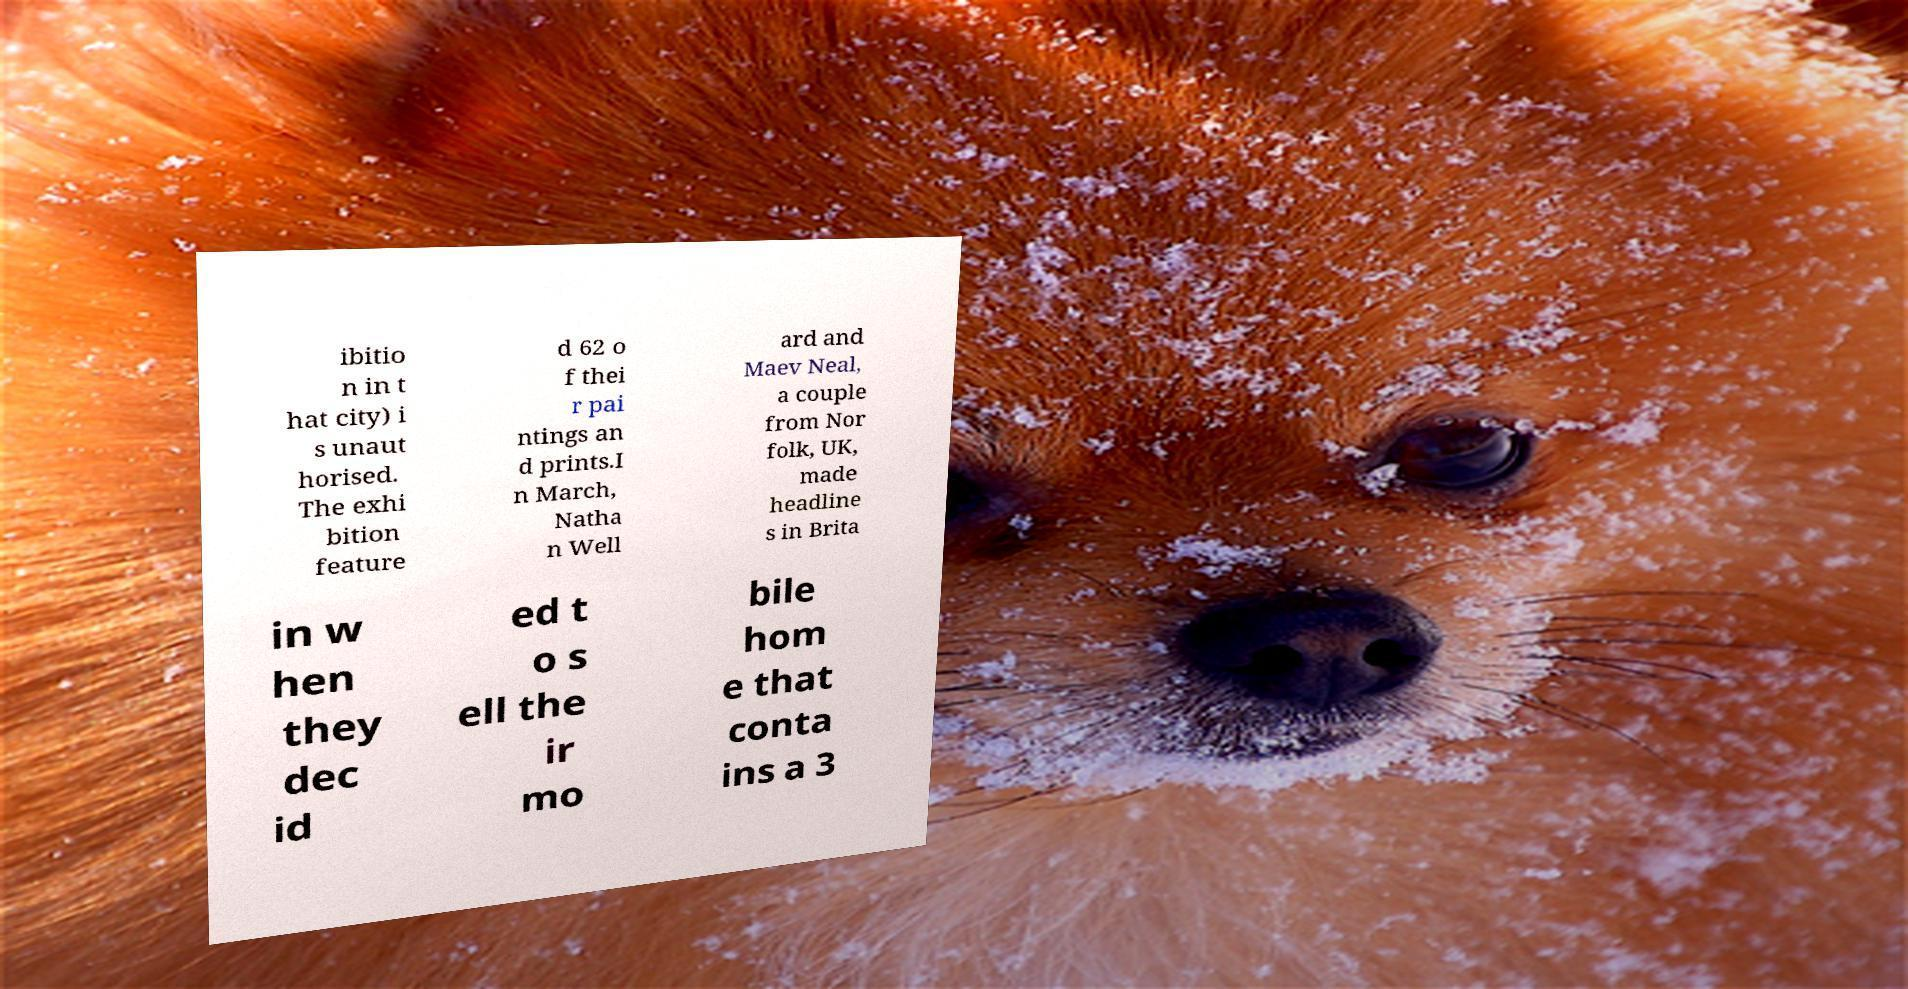Could you extract and type out the text from this image? ibitio n in t hat city) i s unaut horised. The exhi bition feature d 62 o f thei r pai ntings an d prints.I n March, Natha n Well ard and Maev Neal, a couple from Nor folk, UK, made headline s in Brita in w hen they dec id ed t o s ell the ir mo bile hom e that conta ins a 3 